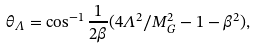Convert formula to latex. <formula><loc_0><loc_0><loc_500><loc_500>\theta _ { \Lambda } = \cos ^ { - 1 } \frac { 1 } { 2 \beta } ( 4 \Lambda ^ { 2 } / M _ { G } ^ { 2 } - 1 - \beta ^ { 2 } ) ,</formula> 